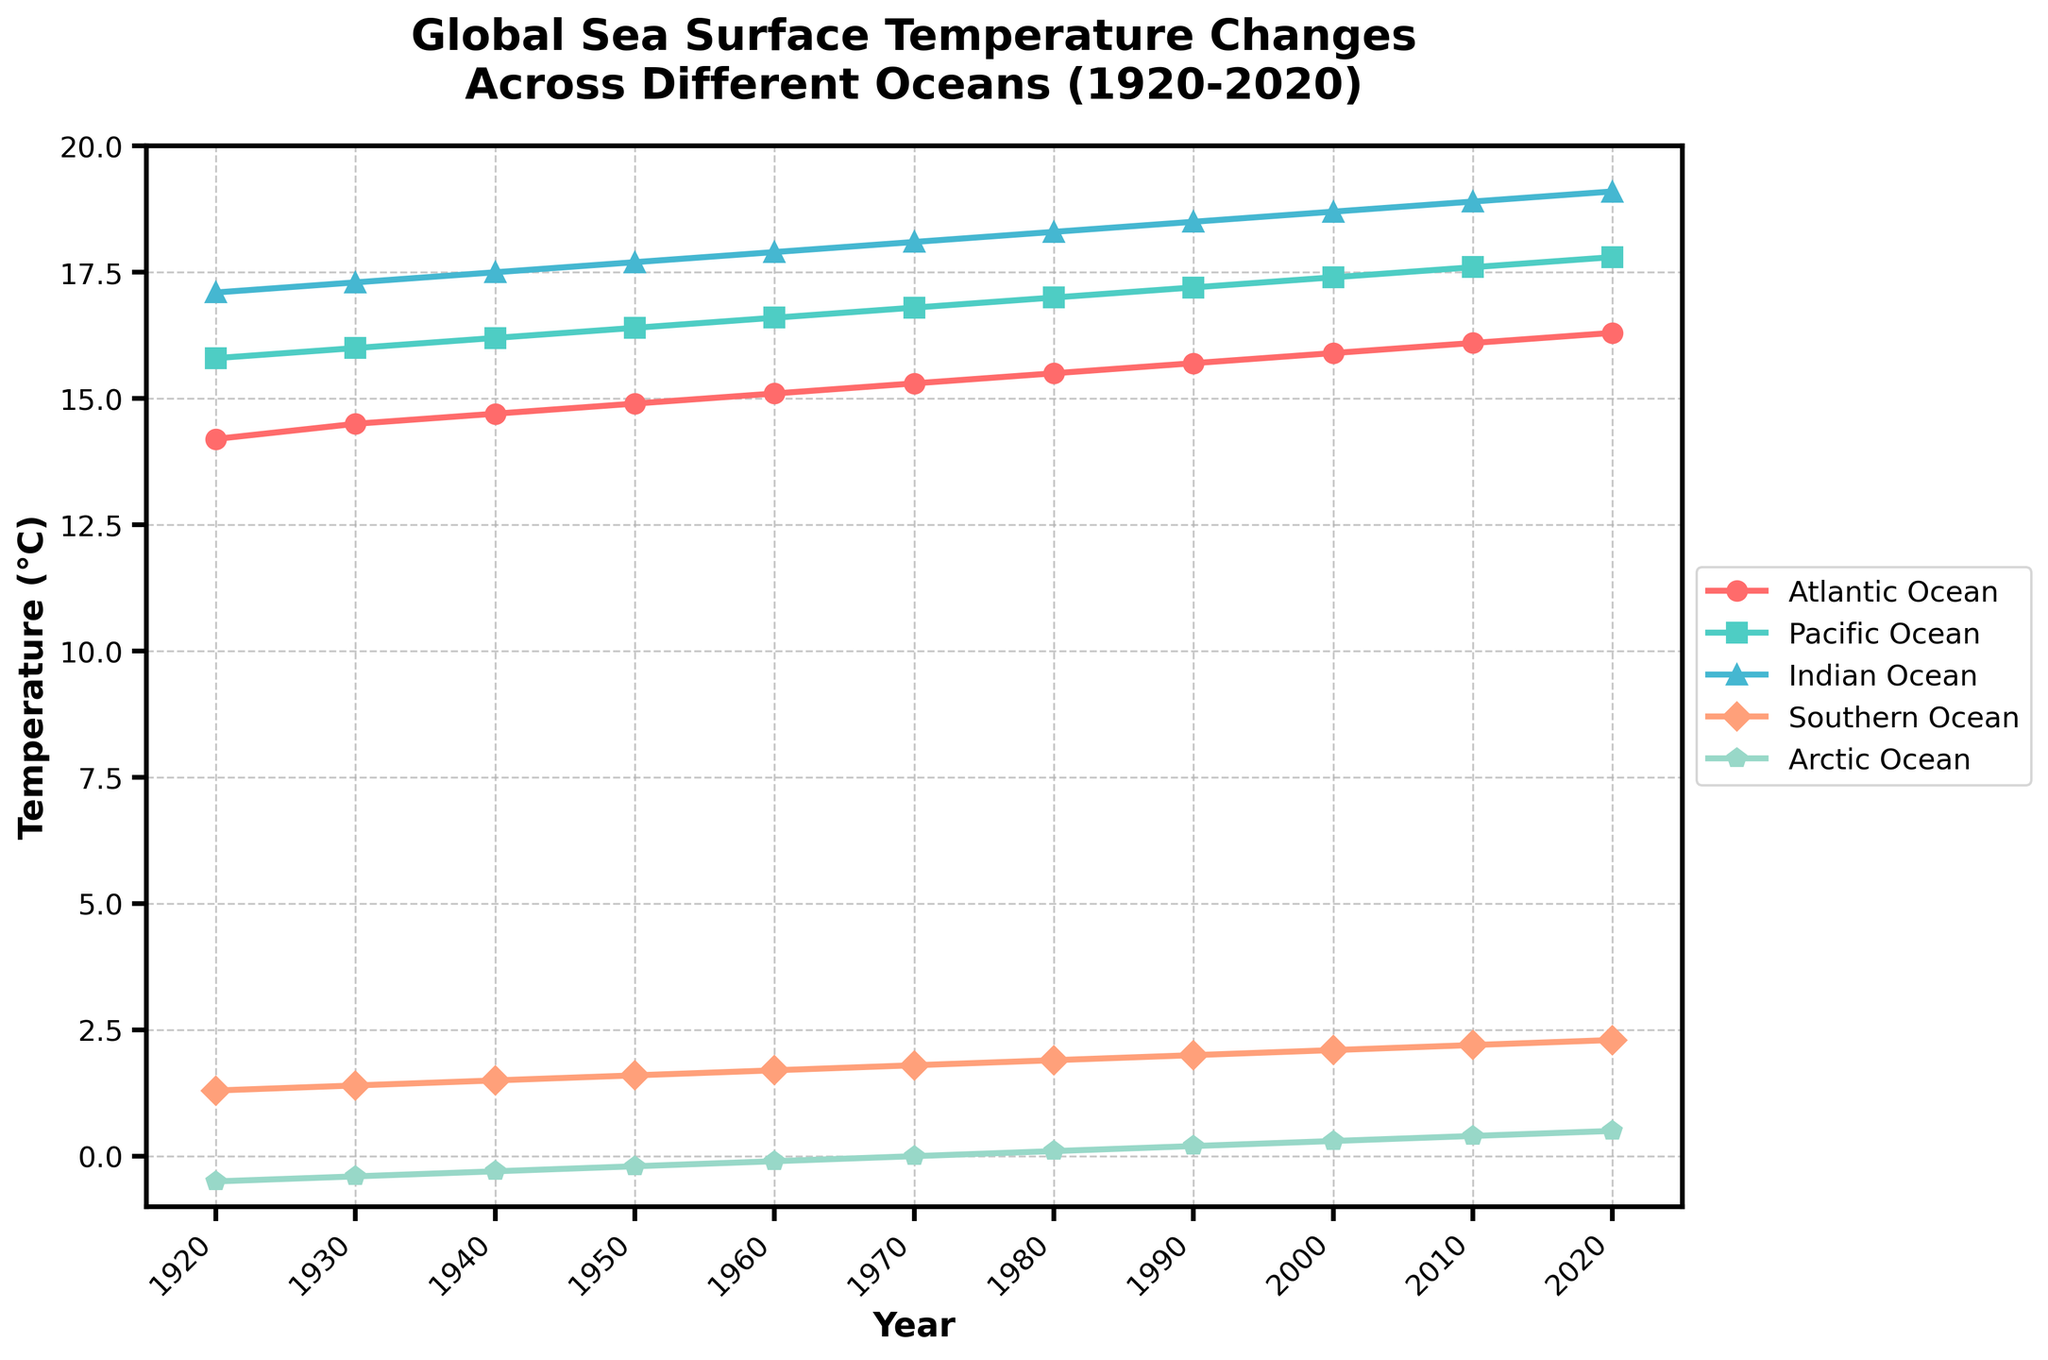What is the overall trend in the Atlantic Ocean's sea surface temperature from 1920 to 2020? Between 1920 and 2020, the line for the Atlantic Ocean consistently trends upwards, indicating an increase in sea surface temperature over this period
Answer: Upward trend How does the sea surface temperature of the Arctic Ocean in 2020 compare to that of the Atlantic Ocean in 1930? In the figure, the Arctic Ocean's temperature in 2020 is around 0.5°C, while the Atlantic Ocean's temperature in 1930 is around 14.5°C. The Arctic Ocean was cooler
Answer: Arctic Ocean is cooler Which ocean shows the greatest increase in temperature from 1920 to 2020? By observing the distances between endpoints of each line in the plot from 1920 to 2020, the Indian Ocean's line shows the largest vertical increase, indicating the greatest temperature rise
Answer: Indian Ocean What is the difference in sea surface temperature for the Southern Ocean between 1950 and 2020? From the plot, the temperature of the Southern Ocean in 1950 is around 1.6°C, and in 2020, it is around 2.3°C. Subtracting these values gives the difference: 2.3 - 1.6 = 0.7
Answer: 0.7°C What can you infer about the temperatures in all oceans around 1940? By looking at the 1940 data points, each line shows a small increase from 1930 and before the more significant rises occurring post-1950, indicating gradual warming around 1940 across all oceans
Answer: Gradual warming Which ocean's sea surface temperature was closest to 18°C in 2000? In the year 2000, the line for the Indian Ocean is approximately at 18.7°C, which is closest to 18°C among the oceans
Answer: Indian Ocean Compare the trends of the Southern Ocean and the Arctic Ocean temperatures. The Southern Ocean's temperature consistently increases from around 1.3°C in 1920 to 2.3°C in 2020, whereas the Arctic Ocean's temperature starts from around -0.5°C and rises to 0.5°C, indicating both have an upward trend but with different starting points and magnitudes
Answer: Both increasing Which decade saw the most rapid increase in the Pacific Ocean's temperature? Observing the slope of the line for the Pacific Ocean, the steepest increase occurs between 1930 and 1940, indicating this decade saw the fastest temperature rise
Answer: 1930-1940 What is the average sea surface temperature of the Atlantic Ocean for the years provided? Sum of the Atlantic Ocean temperatures from 1920 to 2020: 14.2 + 14.5 + 14.7 + 14.9 + 15.1 + 15.3 + 15.5 + 15.7 + 15.9 + 16.1 + 16.3 = 168.2. Dividing by the number of data points, (168.2 / 11)
Answer: 15.29 Is there any ocean where the temperature decreases over time? Observing all the lines, each ocean shows an upward trend in temperature between 1920 and 2020; no ocean shows a decreasing trend
Answer: No 